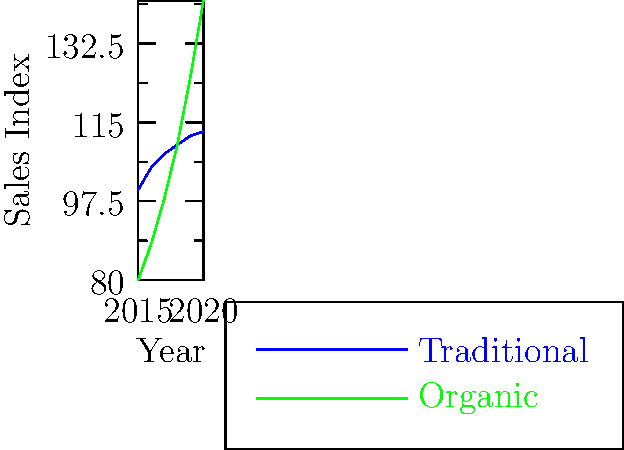Based on the historical sales data shown in the graph, which type of wine production is projected to have higher sales in 2021 if the trends continue? To answer this question, we need to analyze the trends for both traditional and organic wine sales:

1. Traditional wine sales (blue line):
   - Shows a steady but slow increase from 2015 to 2020
   - The growth rate appears to be declining each year
   - In 2020, the sales index is approximately 113

2. Organic wine sales (green line):
   - Demonstrates a more rapid increase, especially from 2017 onwards
   - The growth rate appears to be accelerating
   - In 2020, the sales index is approximately 142

3. Projecting the trends to 2021:
   - Traditional wine: Given the slowing growth rate, it might reach around 115-116
   - Organic wine: With its accelerating growth, it could easily surpass 150

4. Comparison:
   - Organic wine sales are already higher in 2020
   - The gap between organic and traditional is likely to widen further in 2021

Therefore, if these trends continue, organic wine production is projected to have higher sales in 2021.
Answer: Organic wine production 